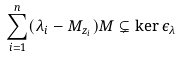<formula> <loc_0><loc_0><loc_500><loc_500>\sum _ { i = 1 } ^ { n } ( \lambda _ { i } - M _ { z _ { i } } ) M \subsetneq \ker \epsilon _ { \lambda }</formula> 